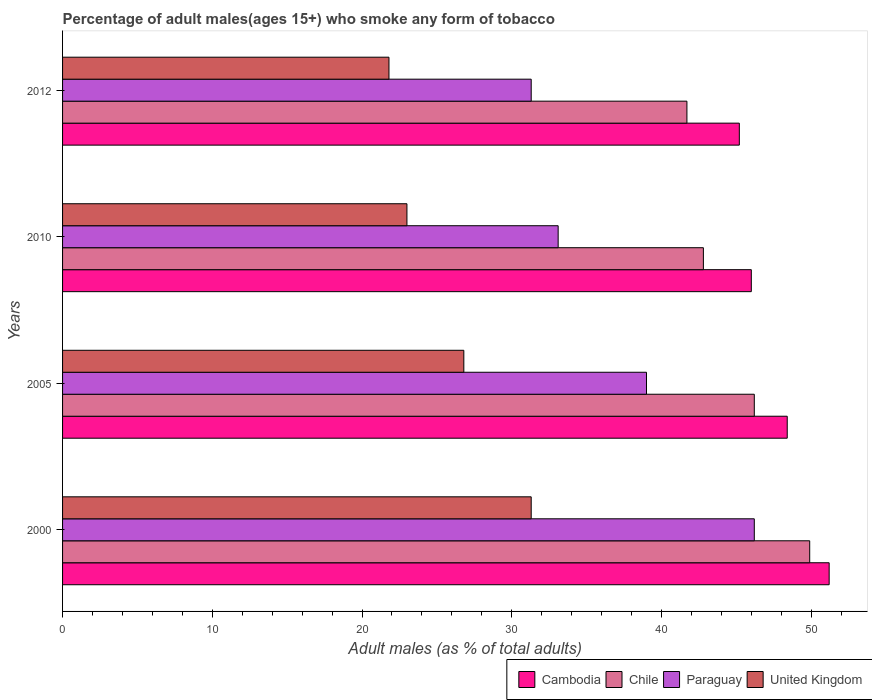How many different coloured bars are there?
Your answer should be very brief. 4. How many groups of bars are there?
Provide a short and direct response. 4. Are the number of bars per tick equal to the number of legend labels?
Offer a terse response. Yes. Are the number of bars on each tick of the Y-axis equal?
Offer a very short reply. Yes. How many bars are there on the 2nd tick from the top?
Provide a short and direct response. 4. How many bars are there on the 3rd tick from the bottom?
Your answer should be compact. 4. What is the label of the 2nd group of bars from the top?
Give a very brief answer. 2010. What is the percentage of adult males who smoke in Chile in 2005?
Provide a short and direct response. 46.2. Across all years, what is the maximum percentage of adult males who smoke in Chile?
Make the answer very short. 49.9. Across all years, what is the minimum percentage of adult males who smoke in Paraguay?
Make the answer very short. 31.3. In which year was the percentage of adult males who smoke in United Kingdom maximum?
Keep it short and to the point. 2000. What is the total percentage of adult males who smoke in Chile in the graph?
Offer a terse response. 180.6. What is the difference between the percentage of adult males who smoke in Chile in 2000 and that in 2012?
Your response must be concise. 8.2. What is the difference between the percentage of adult males who smoke in Cambodia in 2005 and the percentage of adult males who smoke in United Kingdom in 2000?
Your answer should be compact. 17.1. What is the average percentage of adult males who smoke in United Kingdom per year?
Keep it short and to the point. 25.72. In the year 2005, what is the difference between the percentage of adult males who smoke in Cambodia and percentage of adult males who smoke in United Kingdom?
Provide a succinct answer. 21.6. In how many years, is the percentage of adult males who smoke in Cambodia greater than 24 %?
Keep it short and to the point. 4. What is the ratio of the percentage of adult males who smoke in Paraguay in 2000 to that in 2010?
Make the answer very short. 1.4. What is the difference between the highest and the second highest percentage of adult males who smoke in Paraguay?
Offer a very short reply. 7.2. What is the difference between the highest and the lowest percentage of adult males who smoke in Chile?
Give a very brief answer. 8.2. Is the sum of the percentage of adult males who smoke in Chile in 2005 and 2010 greater than the maximum percentage of adult males who smoke in Cambodia across all years?
Your response must be concise. Yes. What does the 4th bar from the top in 2010 represents?
Offer a terse response. Cambodia. What does the 3rd bar from the bottom in 2012 represents?
Make the answer very short. Paraguay. Is it the case that in every year, the sum of the percentage of adult males who smoke in Paraguay and percentage of adult males who smoke in Cambodia is greater than the percentage of adult males who smoke in Chile?
Keep it short and to the point. Yes. How many years are there in the graph?
Keep it short and to the point. 4. Are the values on the major ticks of X-axis written in scientific E-notation?
Keep it short and to the point. No. Does the graph contain any zero values?
Your response must be concise. No. What is the title of the graph?
Your response must be concise. Percentage of adult males(ages 15+) who smoke any form of tobacco. Does "Timor-Leste" appear as one of the legend labels in the graph?
Ensure brevity in your answer.  No. What is the label or title of the X-axis?
Ensure brevity in your answer.  Adult males (as % of total adults). What is the label or title of the Y-axis?
Offer a very short reply. Years. What is the Adult males (as % of total adults) in Cambodia in 2000?
Your response must be concise. 51.2. What is the Adult males (as % of total adults) in Chile in 2000?
Keep it short and to the point. 49.9. What is the Adult males (as % of total adults) in Paraguay in 2000?
Your response must be concise. 46.2. What is the Adult males (as % of total adults) of United Kingdom in 2000?
Give a very brief answer. 31.3. What is the Adult males (as % of total adults) of Cambodia in 2005?
Your response must be concise. 48.4. What is the Adult males (as % of total adults) in Chile in 2005?
Your response must be concise. 46.2. What is the Adult males (as % of total adults) of Paraguay in 2005?
Your answer should be very brief. 39. What is the Adult males (as % of total adults) of United Kingdom in 2005?
Ensure brevity in your answer.  26.8. What is the Adult males (as % of total adults) in Chile in 2010?
Ensure brevity in your answer.  42.8. What is the Adult males (as % of total adults) of Paraguay in 2010?
Your answer should be compact. 33.1. What is the Adult males (as % of total adults) in Cambodia in 2012?
Offer a terse response. 45.2. What is the Adult males (as % of total adults) in Chile in 2012?
Offer a very short reply. 41.7. What is the Adult males (as % of total adults) in Paraguay in 2012?
Make the answer very short. 31.3. What is the Adult males (as % of total adults) in United Kingdom in 2012?
Your answer should be compact. 21.8. Across all years, what is the maximum Adult males (as % of total adults) of Cambodia?
Give a very brief answer. 51.2. Across all years, what is the maximum Adult males (as % of total adults) in Chile?
Ensure brevity in your answer.  49.9. Across all years, what is the maximum Adult males (as % of total adults) in Paraguay?
Provide a succinct answer. 46.2. Across all years, what is the maximum Adult males (as % of total adults) in United Kingdom?
Make the answer very short. 31.3. Across all years, what is the minimum Adult males (as % of total adults) of Cambodia?
Ensure brevity in your answer.  45.2. Across all years, what is the minimum Adult males (as % of total adults) of Chile?
Your response must be concise. 41.7. Across all years, what is the minimum Adult males (as % of total adults) of Paraguay?
Make the answer very short. 31.3. Across all years, what is the minimum Adult males (as % of total adults) of United Kingdom?
Your answer should be very brief. 21.8. What is the total Adult males (as % of total adults) of Cambodia in the graph?
Your response must be concise. 190.8. What is the total Adult males (as % of total adults) of Chile in the graph?
Your answer should be very brief. 180.6. What is the total Adult males (as % of total adults) in Paraguay in the graph?
Keep it short and to the point. 149.6. What is the total Adult males (as % of total adults) in United Kingdom in the graph?
Provide a succinct answer. 102.9. What is the difference between the Adult males (as % of total adults) in Cambodia in 2000 and that in 2005?
Offer a terse response. 2.8. What is the difference between the Adult males (as % of total adults) in Chile in 2000 and that in 2005?
Offer a terse response. 3.7. What is the difference between the Adult males (as % of total adults) of Paraguay in 2000 and that in 2005?
Keep it short and to the point. 7.2. What is the difference between the Adult males (as % of total adults) of United Kingdom in 2000 and that in 2005?
Keep it short and to the point. 4.5. What is the difference between the Adult males (as % of total adults) of Chile in 2000 and that in 2010?
Make the answer very short. 7.1. What is the difference between the Adult males (as % of total adults) of Paraguay in 2000 and that in 2010?
Provide a succinct answer. 13.1. What is the difference between the Adult males (as % of total adults) of Chile in 2000 and that in 2012?
Your response must be concise. 8.2. What is the difference between the Adult males (as % of total adults) in Paraguay in 2000 and that in 2012?
Offer a terse response. 14.9. What is the difference between the Adult males (as % of total adults) of Cambodia in 2005 and that in 2010?
Offer a terse response. 2.4. What is the difference between the Adult males (as % of total adults) in Paraguay in 2005 and that in 2010?
Provide a succinct answer. 5.9. What is the difference between the Adult males (as % of total adults) in United Kingdom in 2005 and that in 2010?
Provide a short and direct response. 3.8. What is the difference between the Adult males (as % of total adults) of Paraguay in 2005 and that in 2012?
Make the answer very short. 7.7. What is the difference between the Adult males (as % of total adults) of United Kingdom in 2005 and that in 2012?
Keep it short and to the point. 5. What is the difference between the Adult males (as % of total adults) in Paraguay in 2010 and that in 2012?
Provide a succinct answer. 1.8. What is the difference between the Adult males (as % of total adults) in Cambodia in 2000 and the Adult males (as % of total adults) in Chile in 2005?
Your answer should be compact. 5. What is the difference between the Adult males (as % of total adults) of Cambodia in 2000 and the Adult males (as % of total adults) of Paraguay in 2005?
Offer a terse response. 12.2. What is the difference between the Adult males (as % of total adults) of Cambodia in 2000 and the Adult males (as % of total adults) of United Kingdom in 2005?
Your response must be concise. 24.4. What is the difference between the Adult males (as % of total adults) in Chile in 2000 and the Adult males (as % of total adults) in United Kingdom in 2005?
Ensure brevity in your answer.  23.1. What is the difference between the Adult males (as % of total adults) in Cambodia in 2000 and the Adult males (as % of total adults) in United Kingdom in 2010?
Offer a very short reply. 28.2. What is the difference between the Adult males (as % of total adults) of Chile in 2000 and the Adult males (as % of total adults) of United Kingdom in 2010?
Offer a terse response. 26.9. What is the difference between the Adult males (as % of total adults) of Paraguay in 2000 and the Adult males (as % of total adults) of United Kingdom in 2010?
Offer a very short reply. 23.2. What is the difference between the Adult males (as % of total adults) in Cambodia in 2000 and the Adult males (as % of total adults) in Chile in 2012?
Offer a very short reply. 9.5. What is the difference between the Adult males (as % of total adults) in Cambodia in 2000 and the Adult males (as % of total adults) in United Kingdom in 2012?
Provide a short and direct response. 29.4. What is the difference between the Adult males (as % of total adults) in Chile in 2000 and the Adult males (as % of total adults) in United Kingdom in 2012?
Give a very brief answer. 28.1. What is the difference between the Adult males (as % of total adults) in Paraguay in 2000 and the Adult males (as % of total adults) in United Kingdom in 2012?
Offer a terse response. 24.4. What is the difference between the Adult males (as % of total adults) in Cambodia in 2005 and the Adult males (as % of total adults) in Chile in 2010?
Your answer should be compact. 5.6. What is the difference between the Adult males (as % of total adults) of Cambodia in 2005 and the Adult males (as % of total adults) of Paraguay in 2010?
Your answer should be very brief. 15.3. What is the difference between the Adult males (as % of total adults) of Cambodia in 2005 and the Adult males (as % of total adults) of United Kingdom in 2010?
Give a very brief answer. 25.4. What is the difference between the Adult males (as % of total adults) of Chile in 2005 and the Adult males (as % of total adults) of United Kingdom in 2010?
Keep it short and to the point. 23.2. What is the difference between the Adult males (as % of total adults) of Paraguay in 2005 and the Adult males (as % of total adults) of United Kingdom in 2010?
Make the answer very short. 16. What is the difference between the Adult males (as % of total adults) of Cambodia in 2005 and the Adult males (as % of total adults) of United Kingdom in 2012?
Offer a very short reply. 26.6. What is the difference between the Adult males (as % of total adults) in Chile in 2005 and the Adult males (as % of total adults) in United Kingdom in 2012?
Offer a terse response. 24.4. What is the difference between the Adult males (as % of total adults) in Cambodia in 2010 and the Adult males (as % of total adults) in Chile in 2012?
Your answer should be compact. 4.3. What is the difference between the Adult males (as % of total adults) in Cambodia in 2010 and the Adult males (as % of total adults) in Paraguay in 2012?
Offer a very short reply. 14.7. What is the difference between the Adult males (as % of total adults) in Cambodia in 2010 and the Adult males (as % of total adults) in United Kingdom in 2012?
Provide a succinct answer. 24.2. What is the difference between the Adult males (as % of total adults) of Chile in 2010 and the Adult males (as % of total adults) of Paraguay in 2012?
Provide a short and direct response. 11.5. What is the difference between the Adult males (as % of total adults) in Chile in 2010 and the Adult males (as % of total adults) in United Kingdom in 2012?
Your answer should be very brief. 21. What is the difference between the Adult males (as % of total adults) of Paraguay in 2010 and the Adult males (as % of total adults) of United Kingdom in 2012?
Your answer should be compact. 11.3. What is the average Adult males (as % of total adults) of Cambodia per year?
Your response must be concise. 47.7. What is the average Adult males (as % of total adults) in Chile per year?
Keep it short and to the point. 45.15. What is the average Adult males (as % of total adults) in Paraguay per year?
Provide a short and direct response. 37.4. What is the average Adult males (as % of total adults) of United Kingdom per year?
Make the answer very short. 25.73. In the year 2000, what is the difference between the Adult males (as % of total adults) in Cambodia and Adult males (as % of total adults) in United Kingdom?
Your answer should be very brief. 19.9. In the year 2000, what is the difference between the Adult males (as % of total adults) of Chile and Adult males (as % of total adults) of Paraguay?
Provide a short and direct response. 3.7. In the year 2000, what is the difference between the Adult males (as % of total adults) of Paraguay and Adult males (as % of total adults) of United Kingdom?
Give a very brief answer. 14.9. In the year 2005, what is the difference between the Adult males (as % of total adults) of Cambodia and Adult males (as % of total adults) of Chile?
Your answer should be compact. 2.2. In the year 2005, what is the difference between the Adult males (as % of total adults) of Cambodia and Adult males (as % of total adults) of United Kingdom?
Ensure brevity in your answer.  21.6. In the year 2005, what is the difference between the Adult males (as % of total adults) of Chile and Adult males (as % of total adults) of Paraguay?
Make the answer very short. 7.2. In the year 2010, what is the difference between the Adult males (as % of total adults) in Chile and Adult males (as % of total adults) in United Kingdom?
Provide a short and direct response. 19.8. In the year 2010, what is the difference between the Adult males (as % of total adults) of Paraguay and Adult males (as % of total adults) of United Kingdom?
Provide a succinct answer. 10.1. In the year 2012, what is the difference between the Adult males (as % of total adults) in Cambodia and Adult males (as % of total adults) in Chile?
Your answer should be compact. 3.5. In the year 2012, what is the difference between the Adult males (as % of total adults) of Cambodia and Adult males (as % of total adults) of Paraguay?
Provide a short and direct response. 13.9. In the year 2012, what is the difference between the Adult males (as % of total adults) of Cambodia and Adult males (as % of total adults) of United Kingdom?
Offer a very short reply. 23.4. What is the ratio of the Adult males (as % of total adults) of Cambodia in 2000 to that in 2005?
Offer a terse response. 1.06. What is the ratio of the Adult males (as % of total adults) in Chile in 2000 to that in 2005?
Provide a short and direct response. 1.08. What is the ratio of the Adult males (as % of total adults) of Paraguay in 2000 to that in 2005?
Provide a short and direct response. 1.18. What is the ratio of the Adult males (as % of total adults) of United Kingdom in 2000 to that in 2005?
Your answer should be very brief. 1.17. What is the ratio of the Adult males (as % of total adults) in Cambodia in 2000 to that in 2010?
Give a very brief answer. 1.11. What is the ratio of the Adult males (as % of total adults) of Chile in 2000 to that in 2010?
Offer a very short reply. 1.17. What is the ratio of the Adult males (as % of total adults) in Paraguay in 2000 to that in 2010?
Your answer should be compact. 1.4. What is the ratio of the Adult males (as % of total adults) in United Kingdom in 2000 to that in 2010?
Your response must be concise. 1.36. What is the ratio of the Adult males (as % of total adults) in Cambodia in 2000 to that in 2012?
Your answer should be compact. 1.13. What is the ratio of the Adult males (as % of total adults) in Chile in 2000 to that in 2012?
Provide a succinct answer. 1.2. What is the ratio of the Adult males (as % of total adults) of Paraguay in 2000 to that in 2012?
Offer a terse response. 1.48. What is the ratio of the Adult males (as % of total adults) in United Kingdom in 2000 to that in 2012?
Provide a succinct answer. 1.44. What is the ratio of the Adult males (as % of total adults) in Cambodia in 2005 to that in 2010?
Your answer should be compact. 1.05. What is the ratio of the Adult males (as % of total adults) in Chile in 2005 to that in 2010?
Provide a succinct answer. 1.08. What is the ratio of the Adult males (as % of total adults) in Paraguay in 2005 to that in 2010?
Offer a very short reply. 1.18. What is the ratio of the Adult males (as % of total adults) in United Kingdom in 2005 to that in 2010?
Provide a short and direct response. 1.17. What is the ratio of the Adult males (as % of total adults) in Cambodia in 2005 to that in 2012?
Offer a terse response. 1.07. What is the ratio of the Adult males (as % of total adults) in Chile in 2005 to that in 2012?
Offer a very short reply. 1.11. What is the ratio of the Adult males (as % of total adults) in Paraguay in 2005 to that in 2012?
Your answer should be very brief. 1.25. What is the ratio of the Adult males (as % of total adults) in United Kingdom in 2005 to that in 2012?
Keep it short and to the point. 1.23. What is the ratio of the Adult males (as % of total adults) in Cambodia in 2010 to that in 2012?
Ensure brevity in your answer.  1.02. What is the ratio of the Adult males (as % of total adults) of Chile in 2010 to that in 2012?
Keep it short and to the point. 1.03. What is the ratio of the Adult males (as % of total adults) of Paraguay in 2010 to that in 2012?
Your answer should be compact. 1.06. What is the ratio of the Adult males (as % of total adults) in United Kingdom in 2010 to that in 2012?
Make the answer very short. 1.05. What is the difference between the highest and the lowest Adult males (as % of total adults) in Paraguay?
Your answer should be very brief. 14.9. 